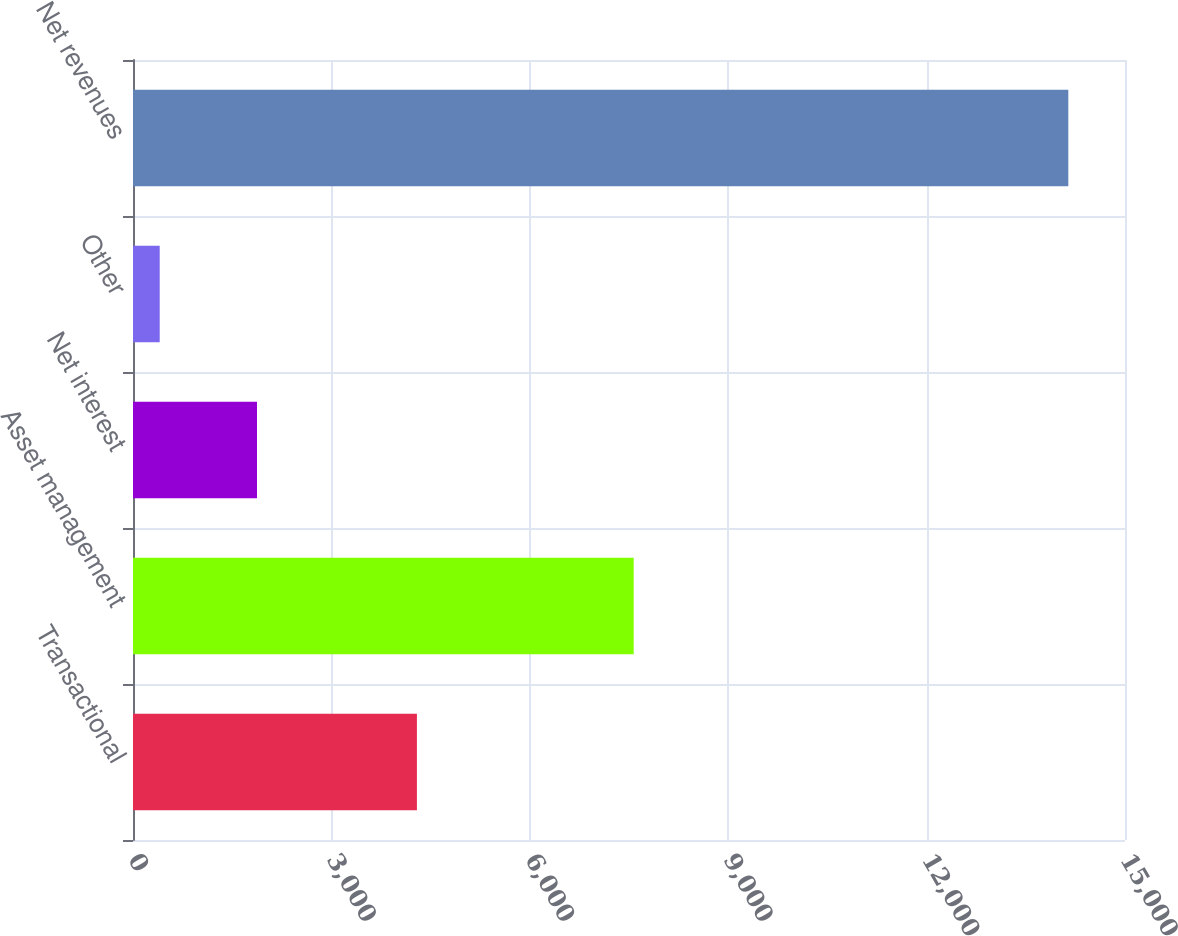<chart> <loc_0><loc_0><loc_500><loc_500><bar_chart><fcel>Transactional<fcel>Asset management<fcel>Net interest<fcel>Other<fcel>Net revenues<nl><fcel>4293<fcel>7571<fcel>1875<fcel>404<fcel>14143<nl></chart> 